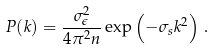Convert formula to latex. <formula><loc_0><loc_0><loc_500><loc_500>P ( k ) = \frac { \sigma _ { \epsilon } ^ { 2 } } { 4 \pi ^ { 2 } n } \exp \left ( - \sigma _ { s } k ^ { 2 } \right ) \, .</formula> 